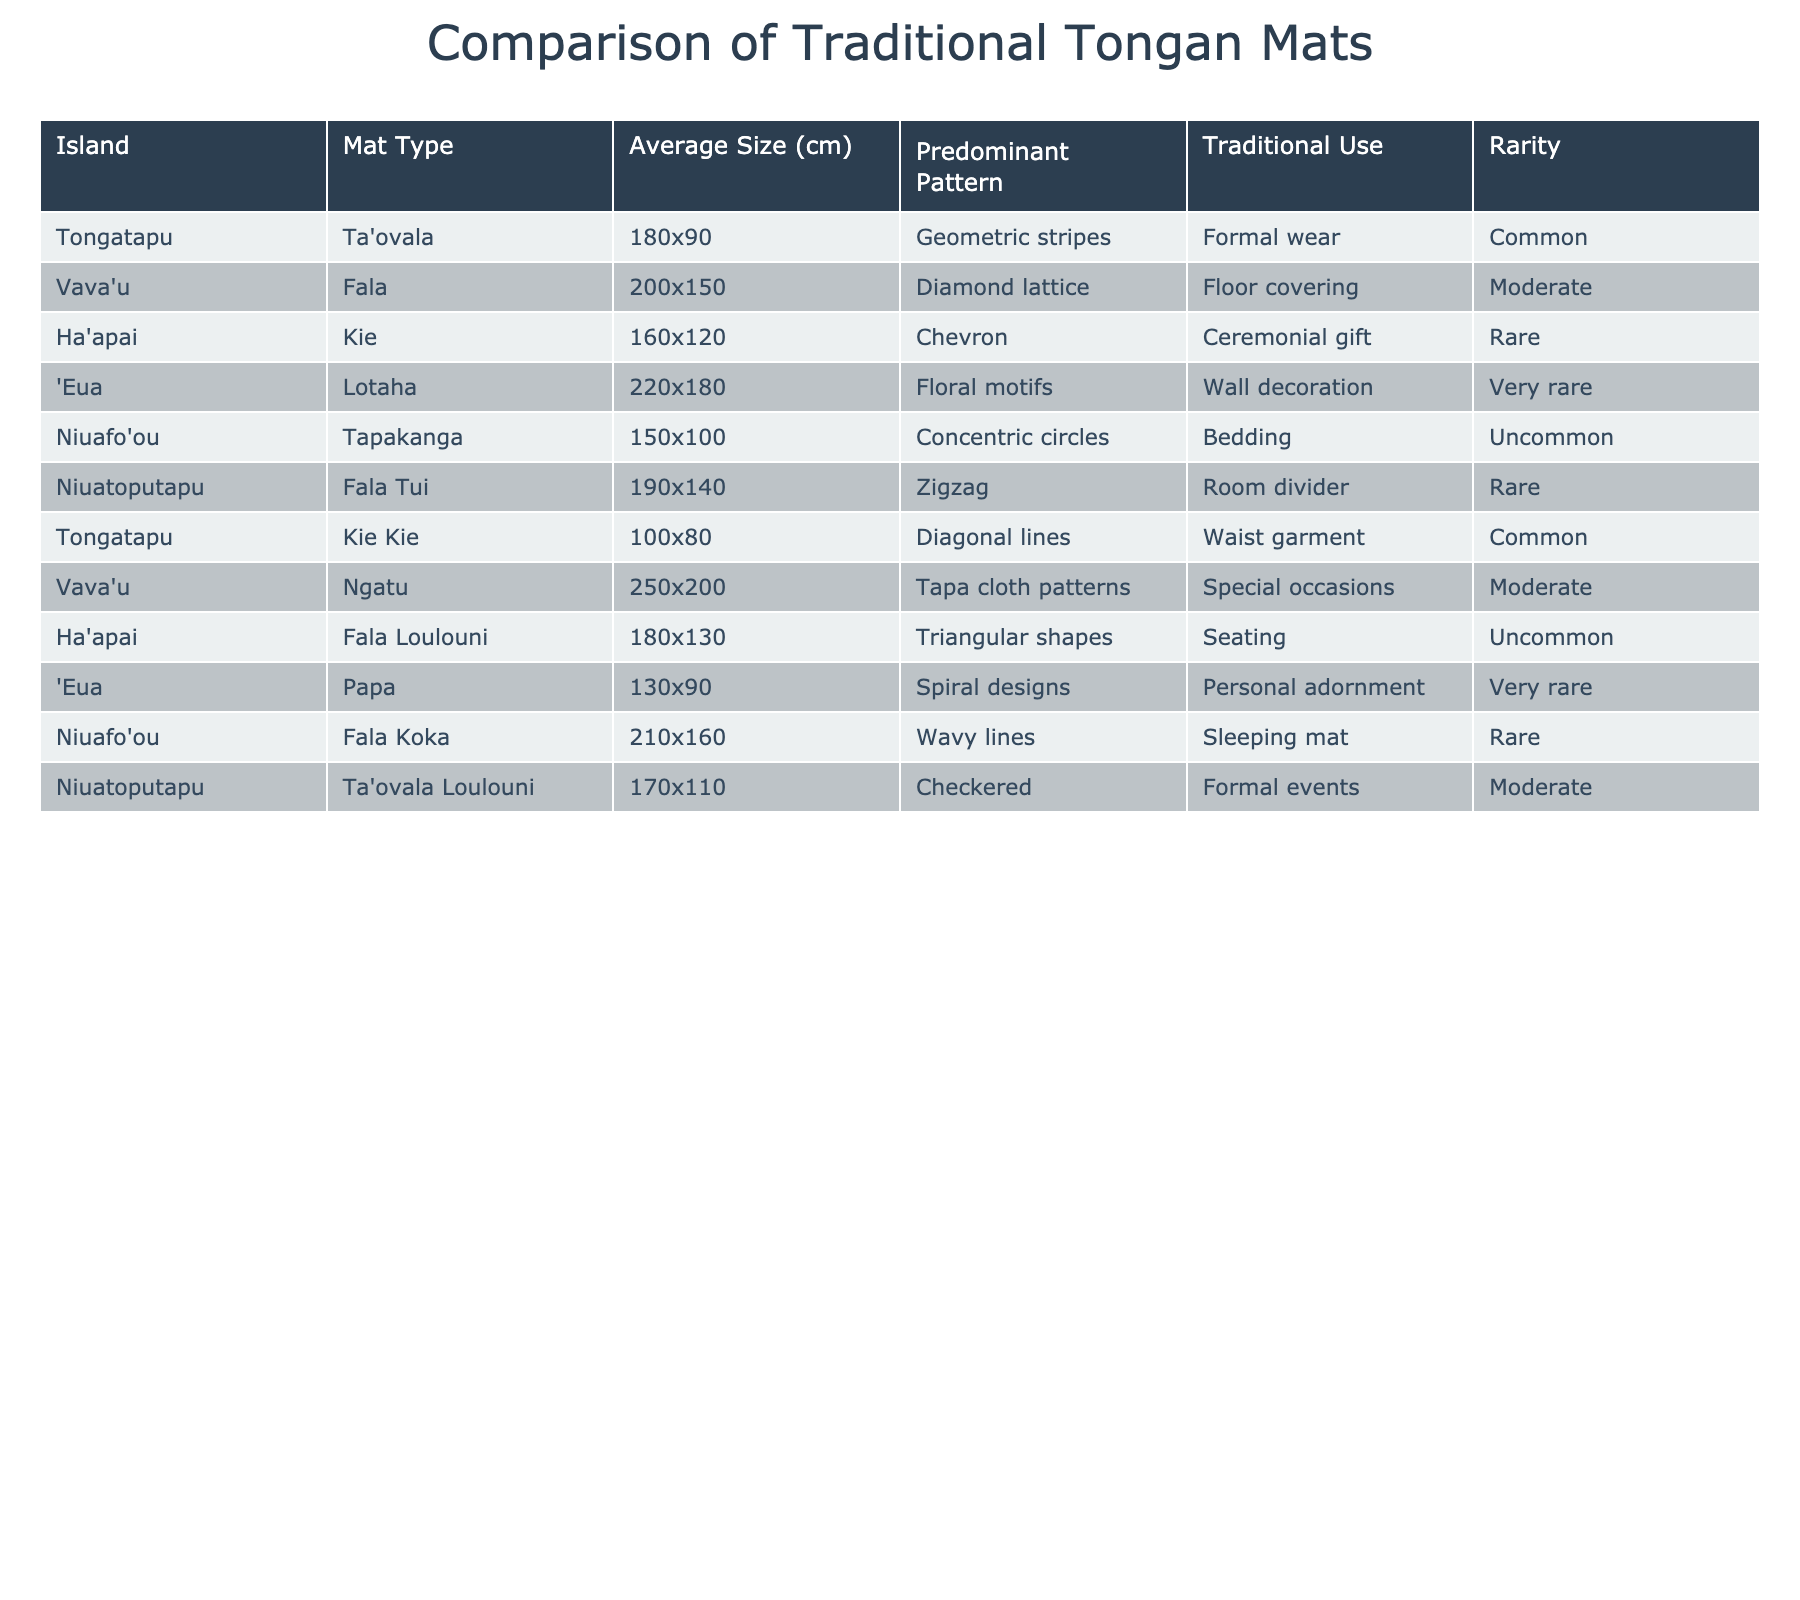What is the average size of mats from Vava'u? The average sizes of mats from Vava'u are 200x150 cm (Fala) and 250x200 cm (Ngatu). To find the average, convert them to square centimeters (30000 cm² and 50000 cm²), sum these values (30000 + 50000 = 80000 cm²), then divide by 2 (80000/2 = 40000 cm²). Converting back to size format gives approximately 200x200 cm.
Answer: 200x200 cm Which island has mats with floral motifs? The only island with mats featuring floral motifs is 'Eua, where this pattern is used on the Lotaha mat for wall decoration.
Answer: 'Eua What is the predominant pattern of the mat Kie Kie from Tongatapu? The table shows that Kie Kie from Tongatapu has diagonal lines as its predominant pattern.
Answer: Diagonal lines Is the mat Fala from Vava'u considered common or rare? According to the table, the Fala from Vava'u is categorized as a moderate rarity mat, meaning it is neither common nor very rare but can be found with some frequency.
Answer: Moderate What is the total number of mats that are used for ceremonial gifts? Two mats are used for ceremonial gifts: the Kie from Ha'apai and the Ngatu from Vava'u. Thus, the total is 2.
Answer: 2 Which is the largest mat by average size and its corresponding island? The largest mat in average size is the Ngatu from Vava'u at 250x200 cm. This is found when comparing all the average sizes listed in the table.
Answer: Vava'u, 250x200 cm Are all mats from Tongatapu common in rarity? In the table, there are two mats from Tongatapu: Ta'ovala is common, while Kie Kie is also categorized as common. Thus, all mats from Tongatapu featured are indeed common.
Answer: Yes How many distinct traditional uses of mats are listed for the Niuafo'ou island? The table lists two distinct traditional uses for mats from Niuafo'ou: the Tapakanga used as bedding and the Fala Koka used as a sleeping mat. Therefore, there are 2 uses.
Answer: 2 What is the average size of mats that are used for personal adornment? The table shows only one mat used for personal adornment, which is 'Papa from 'Eua with an average size of 130x90 cm. Thus, the average size is simply that size, as there's only one data point.
Answer: 130x90 cm Which patterns are considered very rare? The table lists two mats that are very rare: the Lotaha from 'Eua with floral motifs and the Papa also from 'Eua with spiral designs, so these two patterns are both very rare.
Answer: Floral motifs and spiral designs 